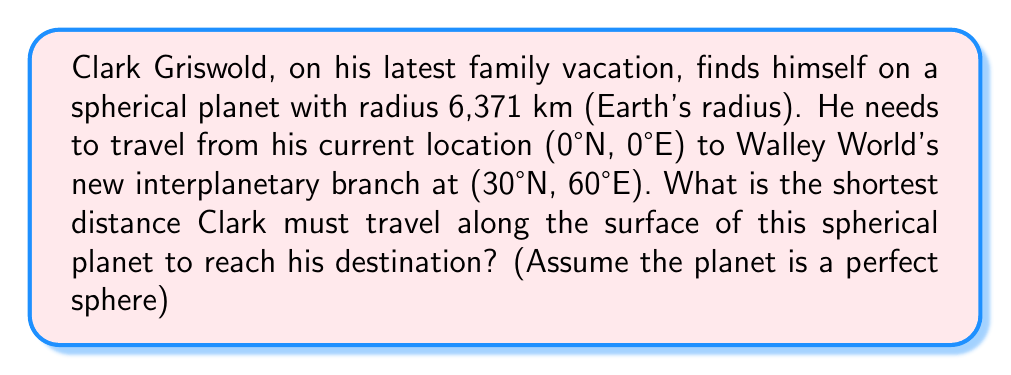Show me your answer to this math problem. To solve this problem, we'll use the great circle distance formula, which gives the shortest path between two points on a sphere. This is analogous to how airplane routes are calculated on Earth.

Step 1: Convert the coordinates to radians.
Let $\phi_1, \lambda_1$ be the latitude and longitude of the starting point, and $\phi_2, \lambda_2$ be those of the destination.

$\phi_1 = 0° = 0$ radians
$\lambda_1 = 0° = 0$ radians
$\phi_2 = 30° = \frac{\pi}{6}$ radians
$\lambda_2 = 60° = \frac{\pi}{3}$ radians

Step 2: Apply the great circle distance formula:
$$d = R \cdot \arccos(\sin\phi_1 \sin\phi_2 + \cos\phi_1 \cos\phi_2 \cos(\lambda_2 - \lambda_1))$$

Where $R$ is the radius of the sphere (6,371 km).

Step 3: Substitute the values:
$$d = 6371 \cdot \arccos(\sin(0) \sin(\frac{\pi}{6}) + \cos(0) \cos(\frac{\pi}{6}) \cos(\frac{\pi}{3} - 0))$$

Step 4: Simplify:
$$d = 6371 \cdot \arccos(0 \cdot \frac{1}{2} + 1 \cdot \frac{\sqrt{3}}{2} \cdot \frac{1}{2})$$
$$d = 6371 \cdot \arccos(\frac{\sqrt{3}}{4})$$

Step 5: Calculate the result:
$$d \approx 6371 \cdot 0.8410 \approx 5357.9 \text{ km}$$

Therefore, Clark Griswold must travel approximately 5,358 km along the surface of the sphere to reach Walley World's new location.
Answer: 5,358 km 